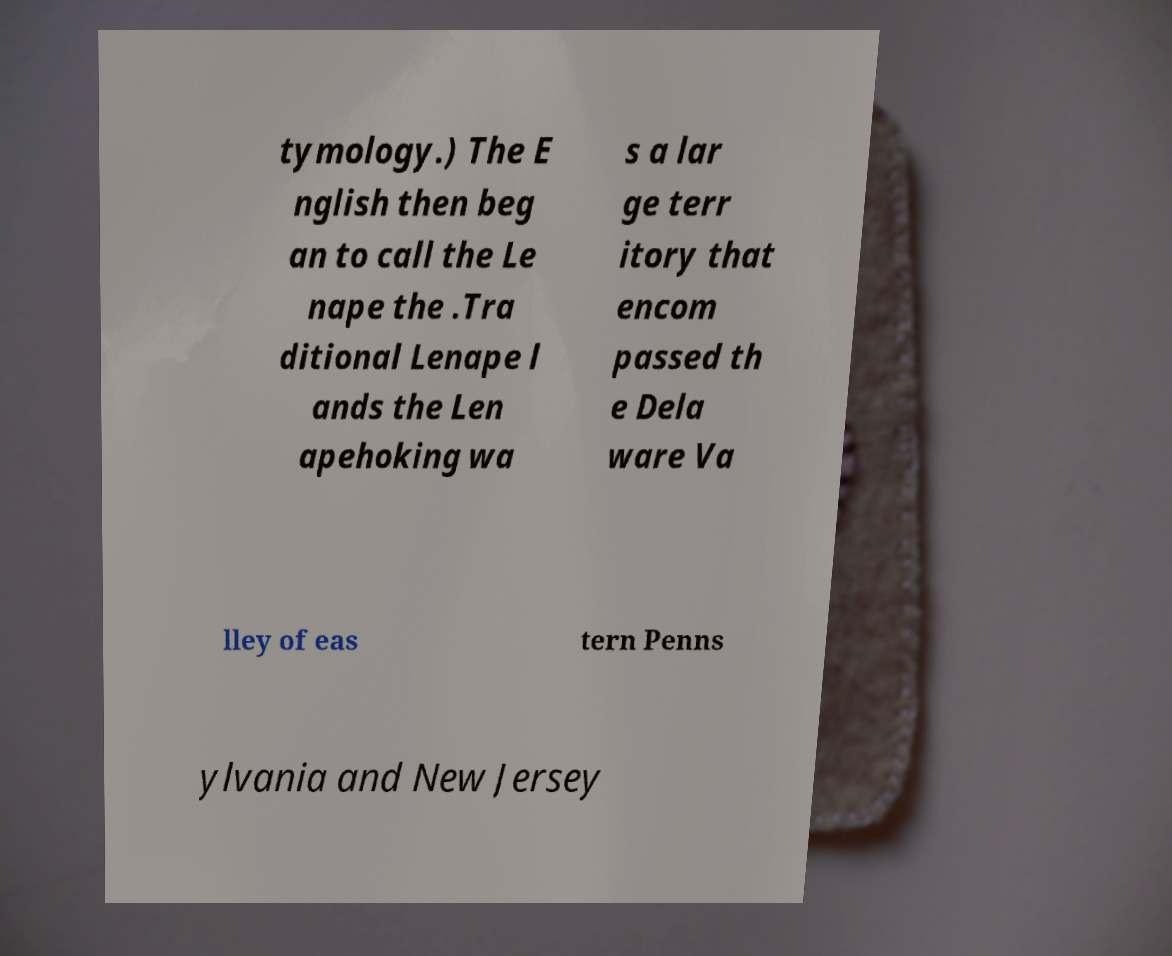Could you extract and type out the text from this image? tymology.) The E nglish then beg an to call the Le nape the .Tra ditional Lenape l ands the Len apehoking wa s a lar ge terr itory that encom passed th e Dela ware Va lley of eas tern Penns ylvania and New Jersey 